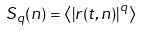Convert formula to latex. <formula><loc_0><loc_0><loc_500><loc_500>S _ { q } ( n ) = \left \langle \left | r ( t , n ) \right | ^ { q } \right \rangle</formula> 